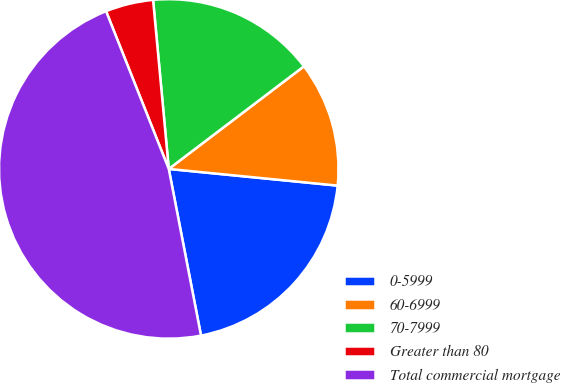Convert chart. <chart><loc_0><loc_0><loc_500><loc_500><pie_chart><fcel>0-5999<fcel>60-6999<fcel>70-7999<fcel>Greater than 80<fcel>Total commercial mortgage<nl><fcel>20.39%<fcel>11.9%<fcel>16.14%<fcel>4.55%<fcel>47.02%<nl></chart> 